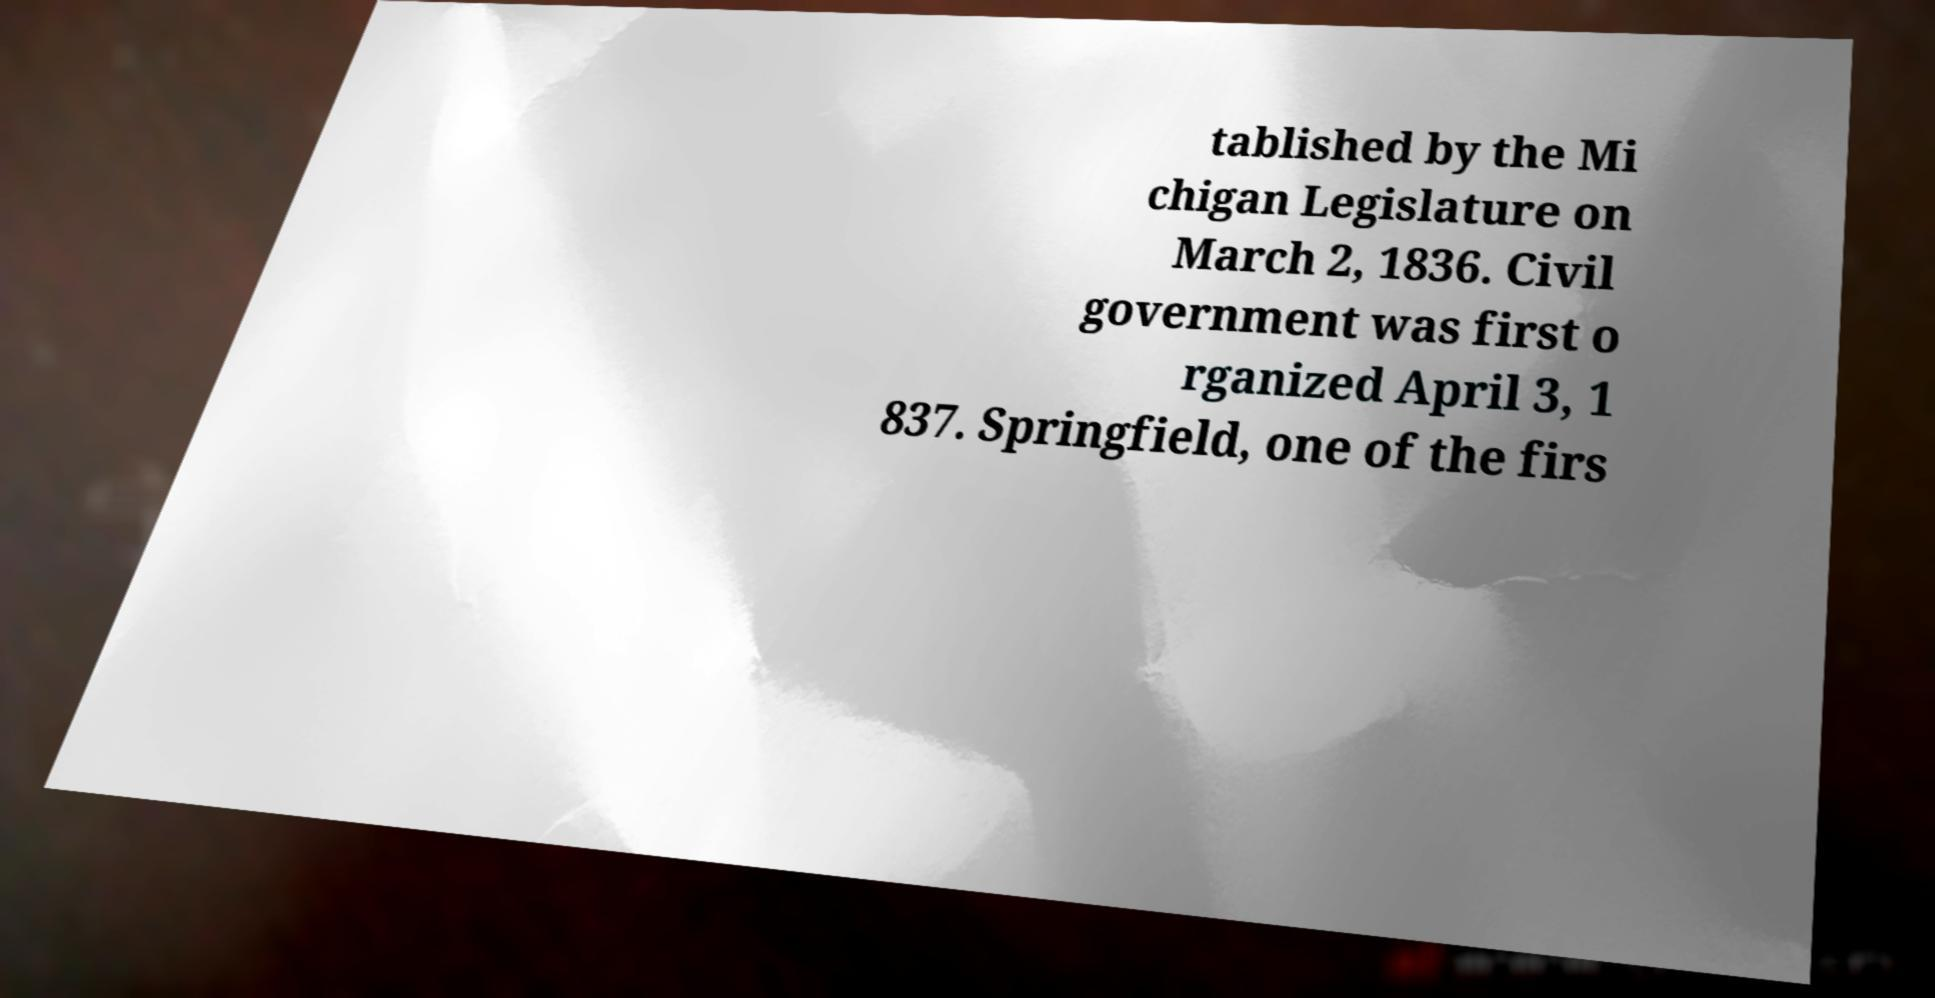I need the written content from this picture converted into text. Can you do that? tablished by the Mi chigan Legislature on March 2, 1836. Civil government was first o rganized April 3, 1 837. Springfield, one of the firs 